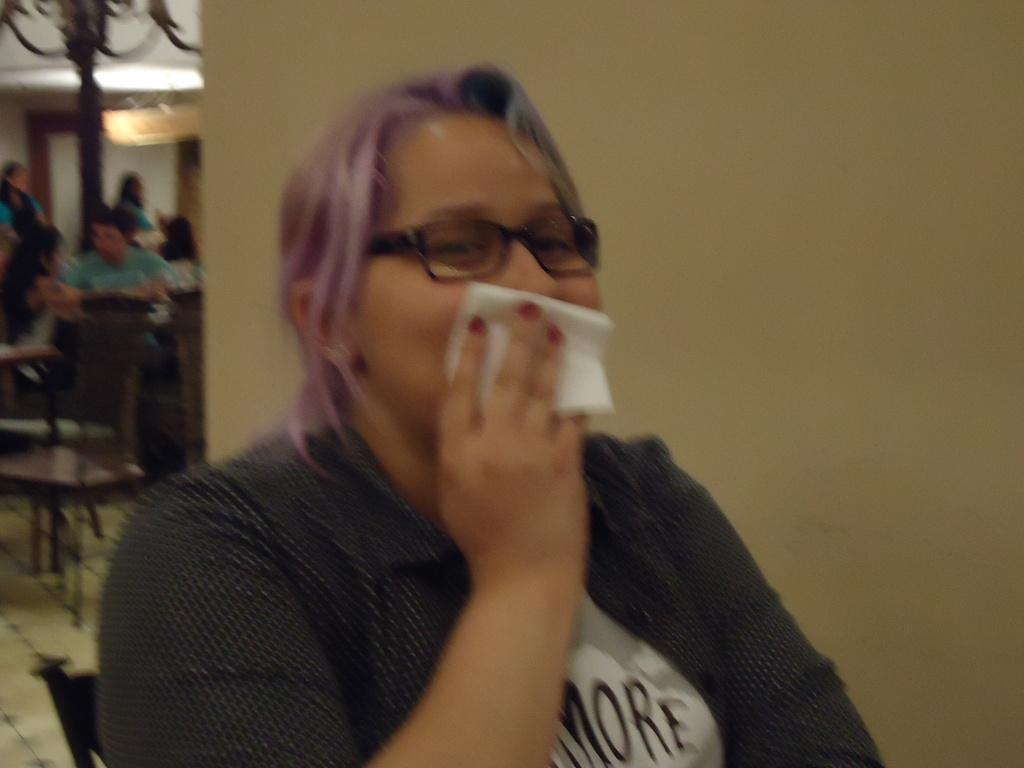Who is the main subject in the image? There is a lady in the center of the image. Are there any other people visible in the image? Yes, there are other people on the left side of the image. What type of writing can be seen on the lady's clothing in the image? There is no writing visible on the lady's clothing in the image. 